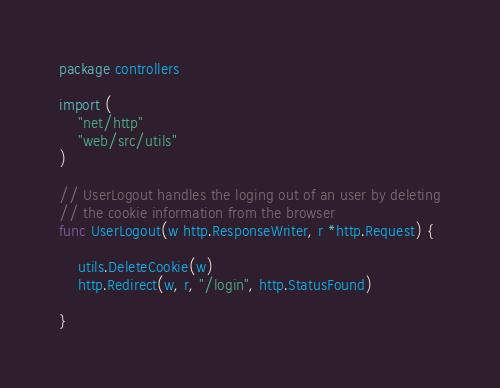<code> <loc_0><loc_0><loc_500><loc_500><_Go_>package controllers

import (
	"net/http"
	"web/src/utils"
)

// UserLogout handles the loging out of an user by deleting
// the cookie information from the browser
func UserLogout(w http.ResponseWriter, r *http.Request) {

	utils.DeleteCookie(w)
	http.Redirect(w, r, "/login", http.StatusFound)

}
</code> 